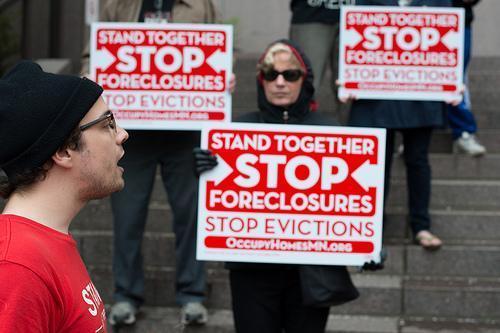How many people are wearing red?
Give a very brief answer. 2. How many people are wearing sandals?
Give a very brief answer. 1. How many people can be seen wearing black gloves?
Give a very brief answer. 1. How many people are holding signs?
Give a very brief answer. 3. 